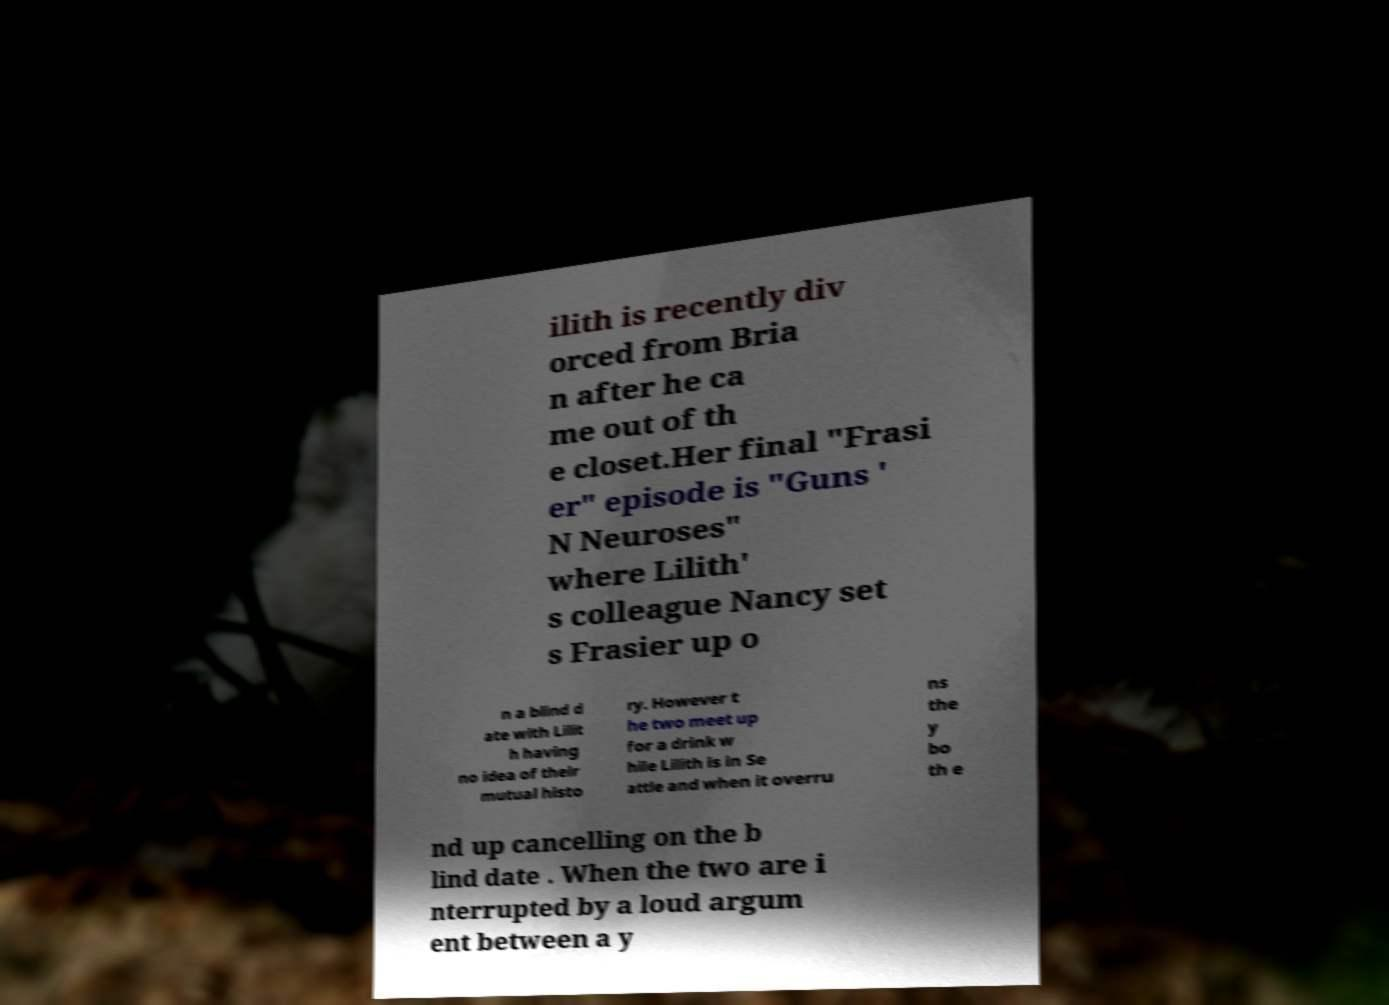Could you assist in decoding the text presented in this image and type it out clearly? ilith is recently div orced from Bria n after he ca me out of th e closet.Her final "Frasi er" episode is "Guns ' N Neuroses" where Lilith' s colleague Nancy set s Frasier up o n a blind d ate with Lilit h having no idea of their mutual histo ry. However t he two meet up for a drink w hile Lilith is in Se attle and when it overru ns the y bo th e nd up cancelling on the b lind date . When the two are i nterrupted by a loud argum ent between a y 